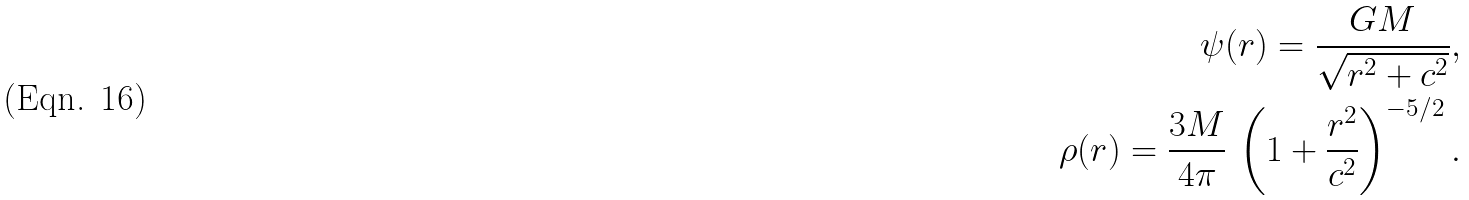Convert formula to latex. <formula><loc_0><loc_0><loc_500><loc_500>\psi ( r ) = \frac { G M } { \sqrt { r ^ { 2 } + c ^ { 2 } } } , \\ \rho ( r ) = \frac { 3 M } { 4 \pi } \, \left ( 1 + \frac { r ^ { 2 } } { c ^ { 2 } } \right ) ^ { - 5 / 2 } .</formula> 